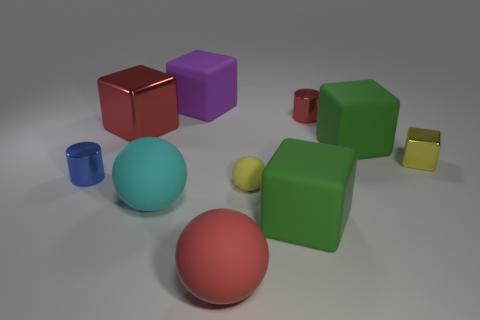There is a big metal block; is it the same color as the tiny cylinder that is to the right of the large red rubber ball?
Make the answer very short. Yes. How many things are cubes or large purple rubber things?
Your answer should be very brief. 5. Does the tiny yellow ball have the same material as the cyan sphere that is in front of the large metallic thing?
Offer a very short reply. Yes. How big is the cylinder to the right of the blue shiny cylinder?
Give a very brief answer. Small. Is the number of big purple things less than the number of shiny cylinders?
Provide a succinct answer. Yes. Are there any other things of the same color as the big metallic object?
Provide a succinct answer. Yes. What is the shape of the red object that is both in front of the red metal cylinder and behind the large red ball?
Provide a short and direct response. Cube. There is a red object behind the large red thing behind the tiny blue shiny cylinder; what shape is it?
Your answer should be compact. Cylinder. Is the tiny yellow rubber object the same shape as the blue metallic object?
Give a very brief answer. No. What is the material of the thing that is the same color as the small metallic block?
Your answer should be very brief. Rubber. 